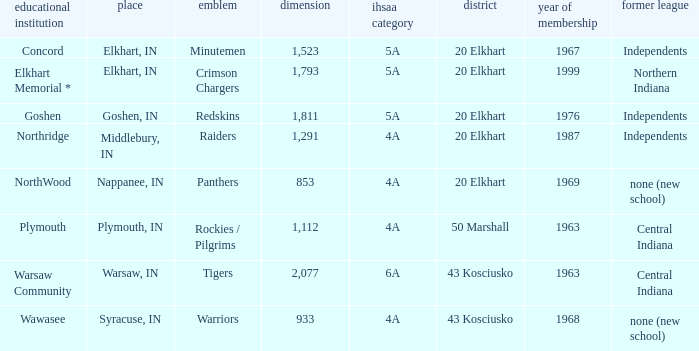What is the size of the team that was previously from Central Indiana conference, and is in IHSSA Class 4a? 1112.0. 